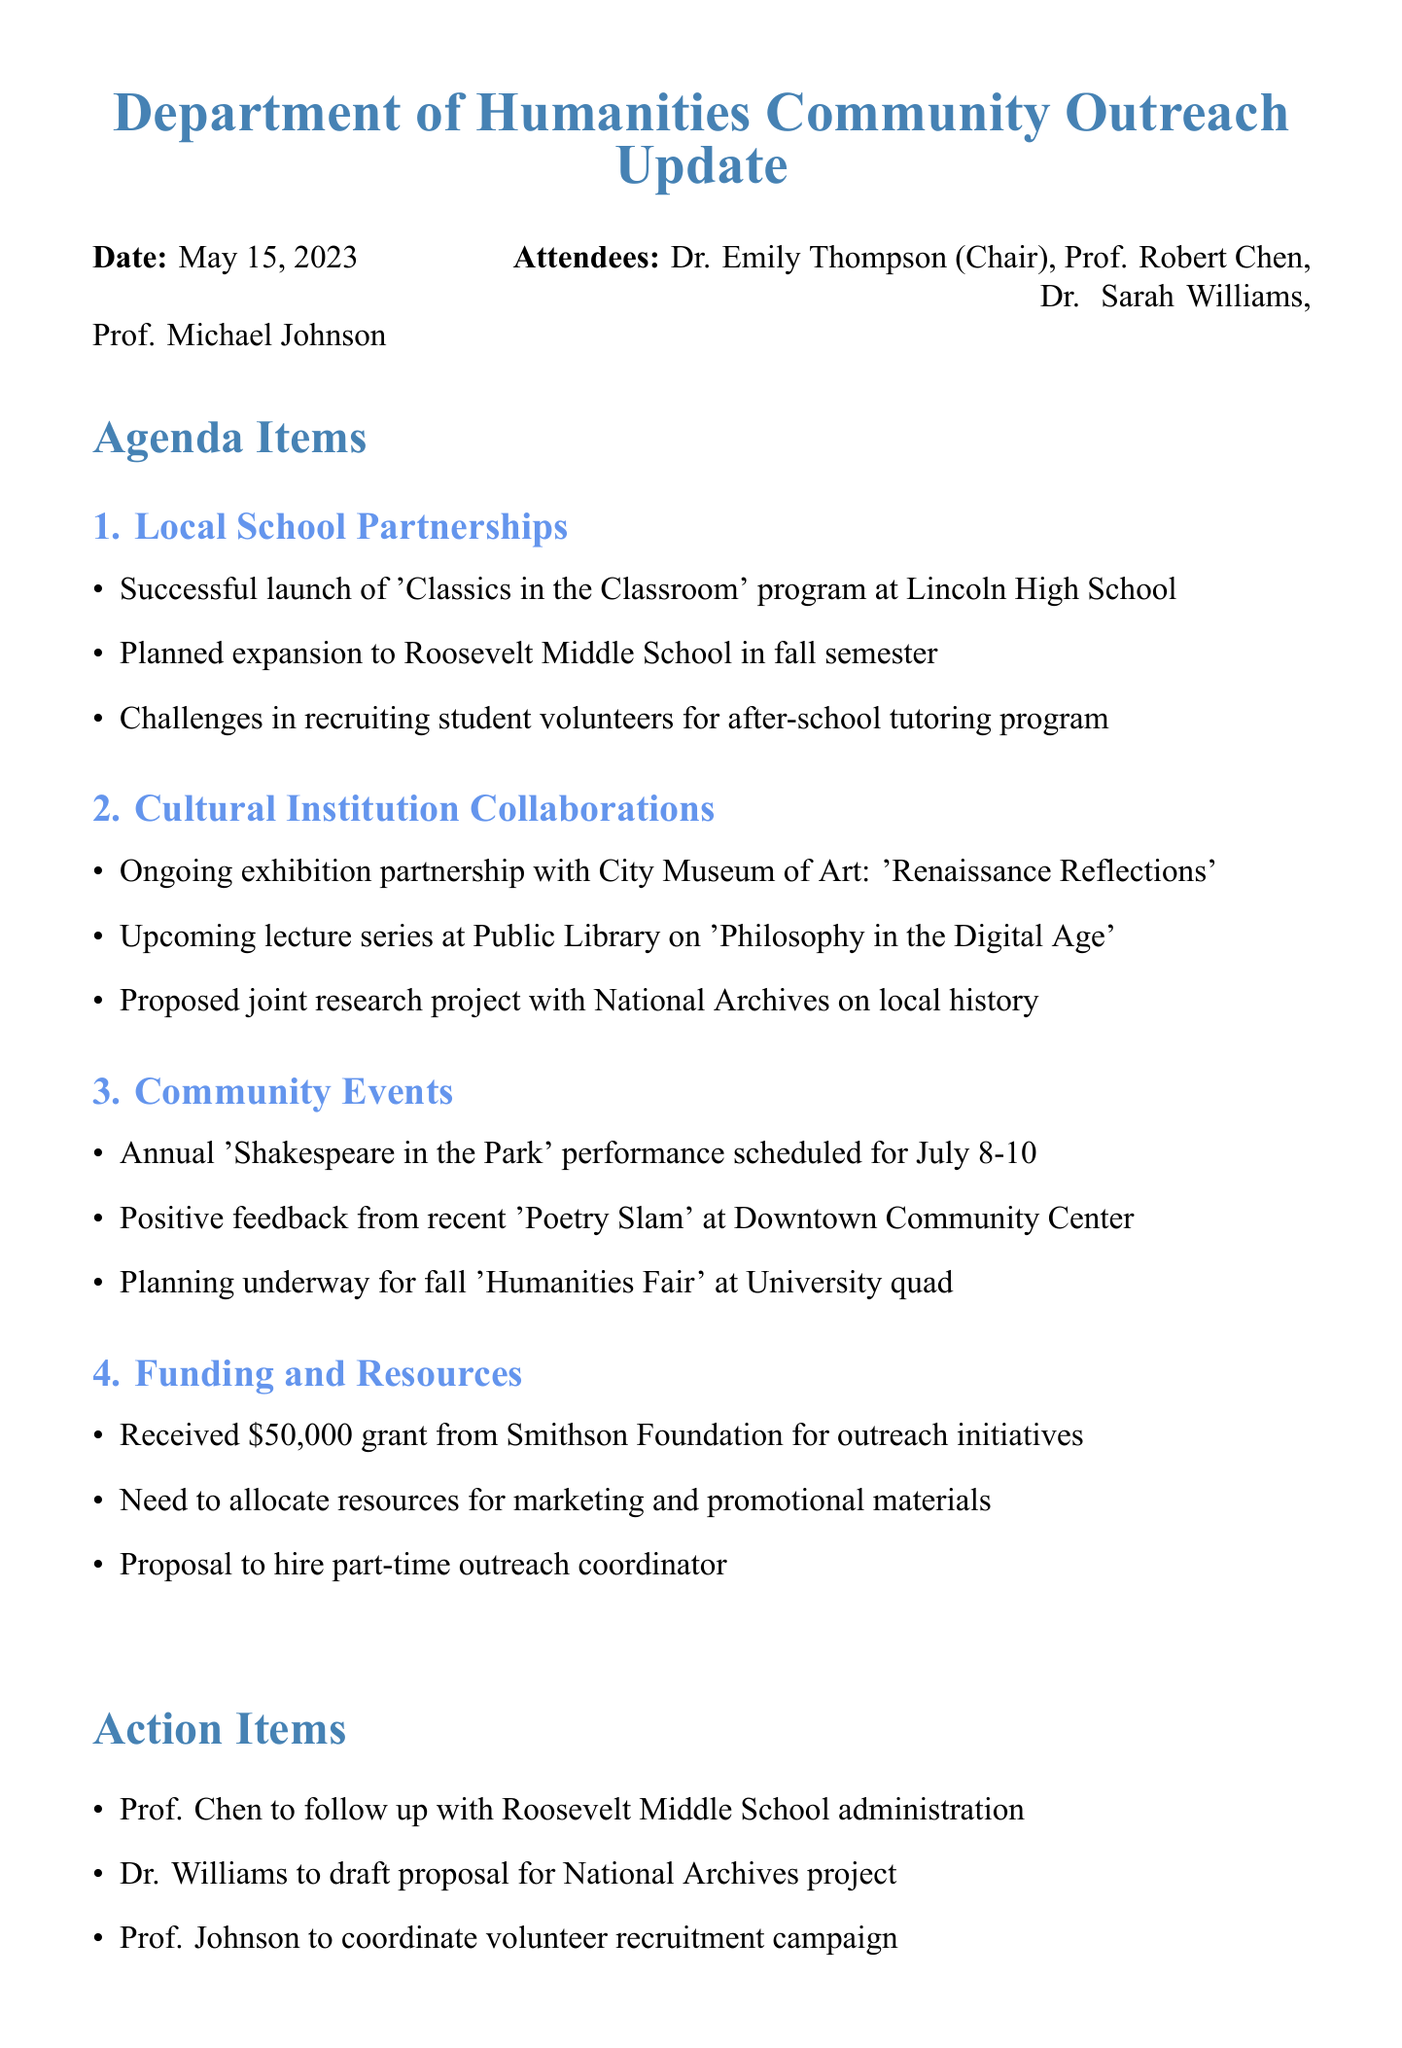what is the date of the meeting? The date is provided in the document header, stating when the community outreach update meeting took place.
Answer: May 15, 2023 who is the chair of the meeting? The chair of the meeting is listed among the attendees at the beginning of the document.
Answer: Dr. Emily Thompson what program was launched at Lincoln High School? The program is mentioned in the Local School Partnerships section detailing a successful initiative.
Answer: Classics in the Classroom how much grant was received from the Smithson Foundation? The funding details are specified in the Funding and Resources section of the meeting minutes.
Answer: $50,000 what is the upcoming community event scheduled for July? This event is listed as part of the Community Events agenda item and specifies the date for the event.
Answer: Shakespeare in the Park what are the challenges mentioned regarding the tutoring program? The challenges are highlighted under the Local School Partnerships section of the document.
Answer: Recruiting student volunteers what action item involves coordination of a volunteer campaign? The action items section outlines specific responsibilities assigned to attendees, including this one.
Answer: Prof. Johnson to coordinate volunteer recruitment campaign which cultural institution is collaborating on an exhibition? The collaboration details are provided in the Cultural Institution Collaborations section covering ongoing partnerships.
Answer: City Museum of Art 